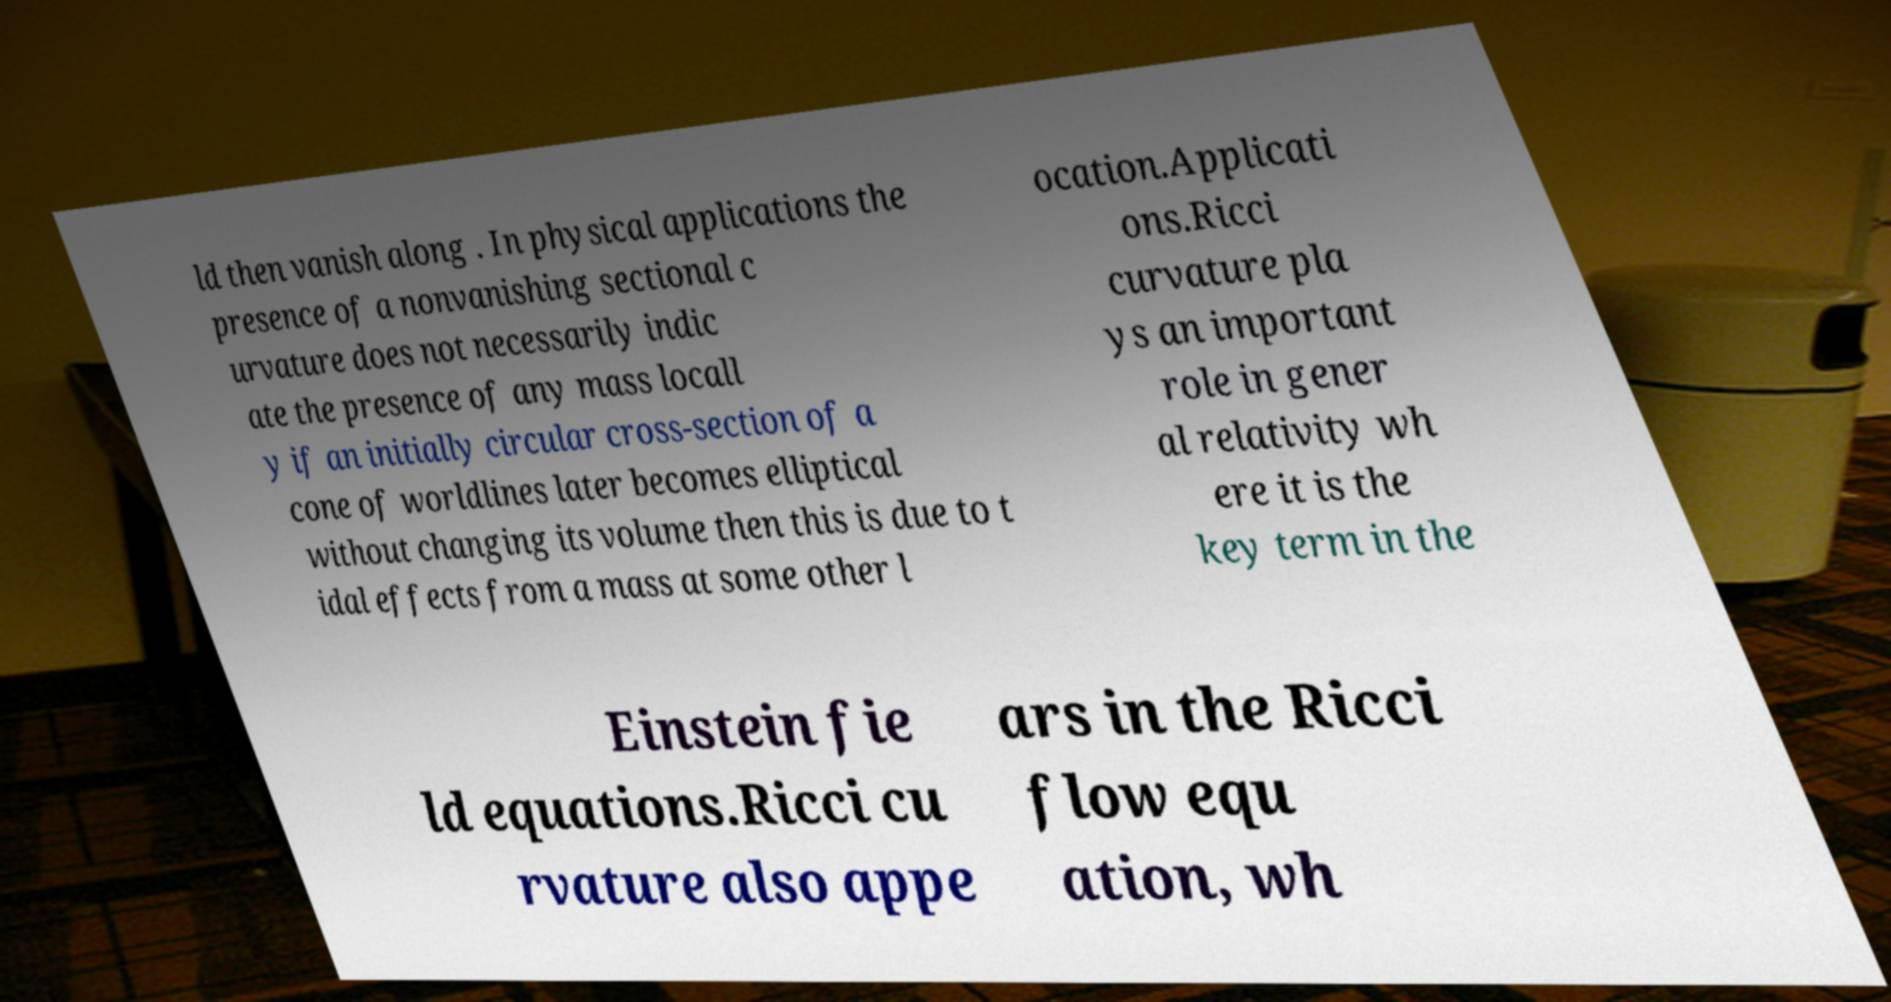Can you read and provide the text displayed in the image?This photo seems to have some interesting text. Can you extract and type it out for me? ld then vanish along . In physical applications the presence of a nonvanishing sectional c urvature does not necessarily indic ate the presence of any mass locall y if an initially circular cross-section of a cone of worldlines later becomes elliptical without changing its volume then this is due to t idal effects from a mass at some other l ocation.Applicati ons.Ricci curvature pla ys an important role in gener al relativity wh ere it is the key term in the Einstein fie ld equations.Ricci cu rvature also appe ars in the Ricci flow equ ation, wh 